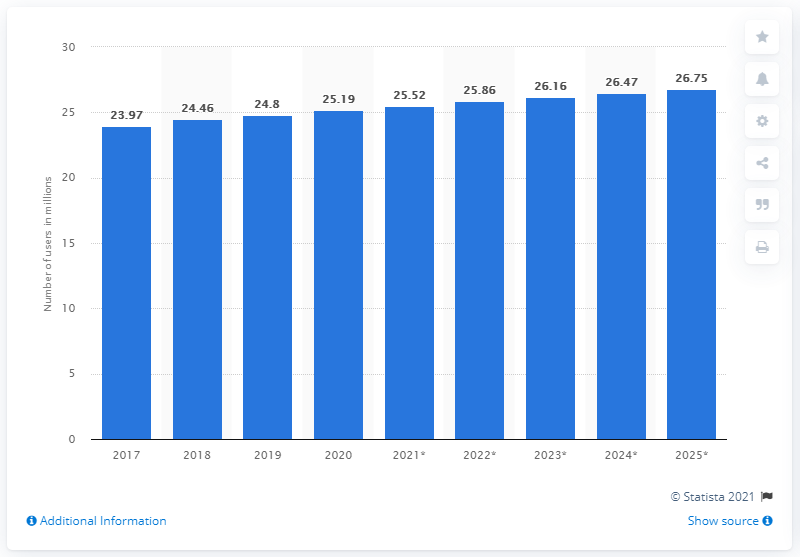Highlight a few significant elements in this photo. In 2020, the number of Facebook users in Canada was 25.19 million. The estimated number of Facebook users in Canada in 2025 is projected to be 26.75 million. 